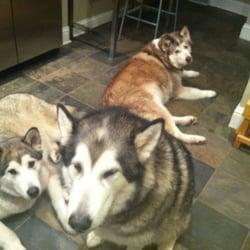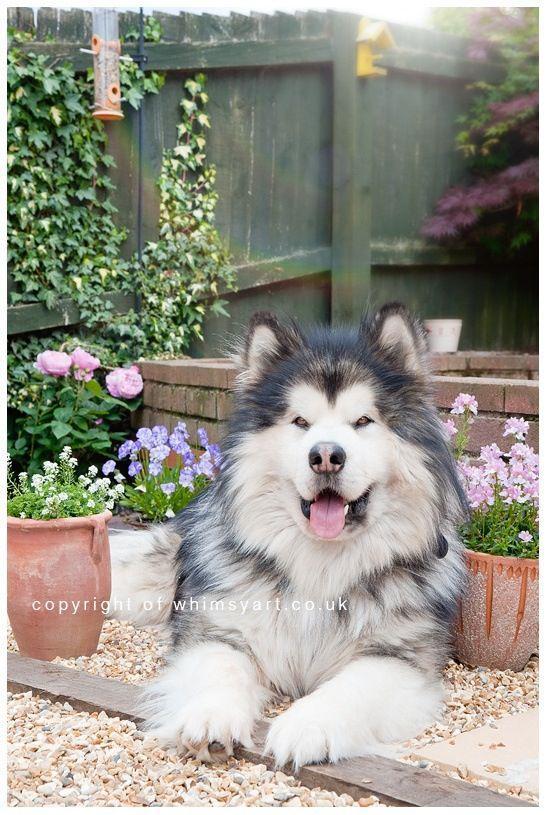The first image is the image on the left, the second image is the image on the right. Considering the images on both sides, is "In one of the images, a sitting dog and a single human are visible." valid? Answer yes or no. No. The first image is the image on the left, the second image is the image on the right. Evaluate the accuracy of this statement regarding the images: "The dogs in the image on the left are out in the snow.". Is it true? Answer yes or no. No. 